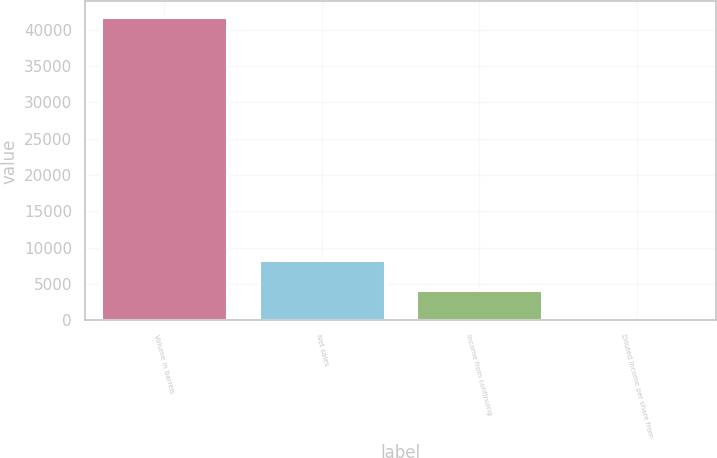<chart> <loc_0><loc_0><loc_500><loc_500><bar_chart><fcel>Volume in barrels<fcel>Net sales<fcel>Income from continuing<fcel>Diluted income per share from<nl><fcel>41806<fcel>8362.92<fcel>4182.54<fcel>2.16<nl></chart> 